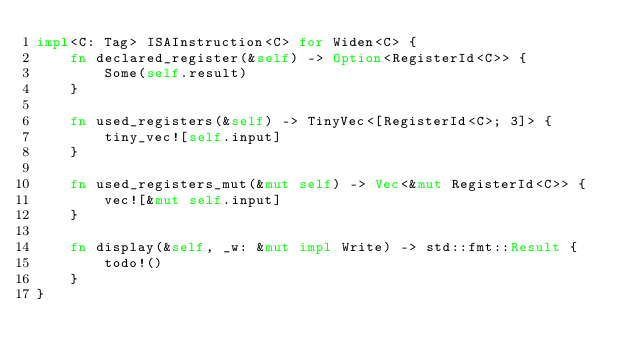Convert code to text. <code><loc_0><loc_0><loc_500><loc_500><_Rust_>impl<C: Tag> ISAInstruction<C> for Widen<C> {
    fn declared_register(&self) -> Option<RegisterId<C>> {
        Some(self.result)
    }

    fn used_registers(&self) -> TinyVec<[RegisterId<C>; 3]> {
        tiny_vec![self.input]
    }

    fn used_registers_mut(&mut self) -> Vec<&mut RegisterId<C>> {
        vec![&mut self.input]
    }

    fn display(&self, _w: &mut impl Write) -> std::fmt::Result {
        todo!()
    }
}
</code> 